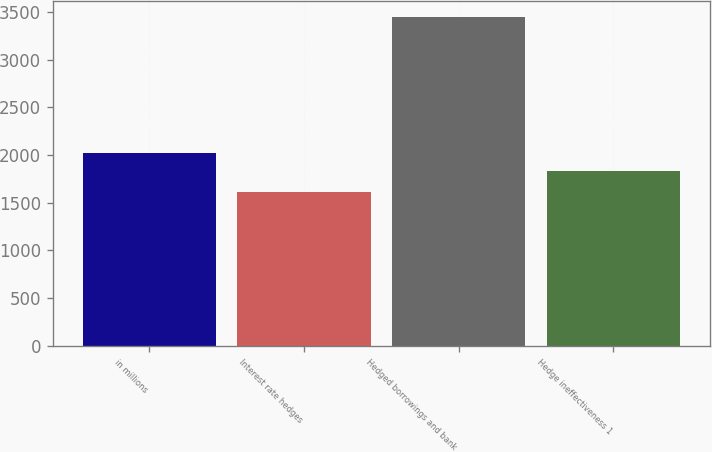Convert chart to OTSL. <chart><loc_0><loc_0><loc_500><loc_500><bar_chart><fcel>in millions<fcel>Interest rate hedges<fcel>Hedged borrowings and bank<fcel>Hedge ineffectiveness 1<nl><fcel>2019<fcel>1617<fcel>3447<fcel>1836<nl></chart> 